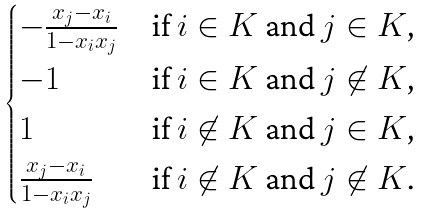<formula> <loc_0><loc_0><loc_500><loc_500>\begin{cases} - \frac { x _ { j } - x _ { i } } { 1 - x _ { i } x _ { j } } & \text {if $i \in K$ and $j \in K$,} \\ - 1 & \text {if $i \in K$ and $j \not\in K$,} \\ 1 & \text {if $i \not\in K$ and $j \in K$,} \\ \frac { x _ { j } - x _ { i } } { 1 - x _ { i } x _ { j } } & \text {if $i \not\in K$ and $j \not\in K$.} \\ \end{cases}</formula> 